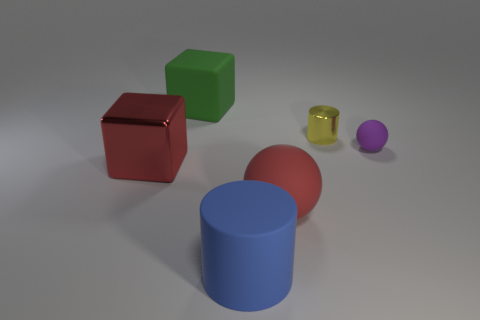What number of cubes are red objects or big red matte things?
Ensure brevity in your answer.  1. What color is the large cylinder that is the same material as the big ball?
Make the answer very short. Blue. Does the small cylinder have the same material as the large red object to the right of the metal cube?
Offer a very short reply. No. What number of things are either blue rubber things or metal cubes?
Your answer should be very brief. 2. What material is the object that is the same color as the shiny cube?
Your answer should be compact. Rubber. Is there a yellow metal object of the same shape as the large green thing?
Offer a very short reply. No. What number of cylinders are in front of the big red shiny object?
Make the answer very short. 1. What material is the large red thing to the left of the large matte thing that is behind the small yellow metallic thing made of?
Your answer should be very brief. Metal. There is a cylinder that is the same size as the purple object; what is its material?
Your response must be concise. Metal. Is there another sphere that has the same size as the purple rubber sphere?
Keep it short and to the point. No. 